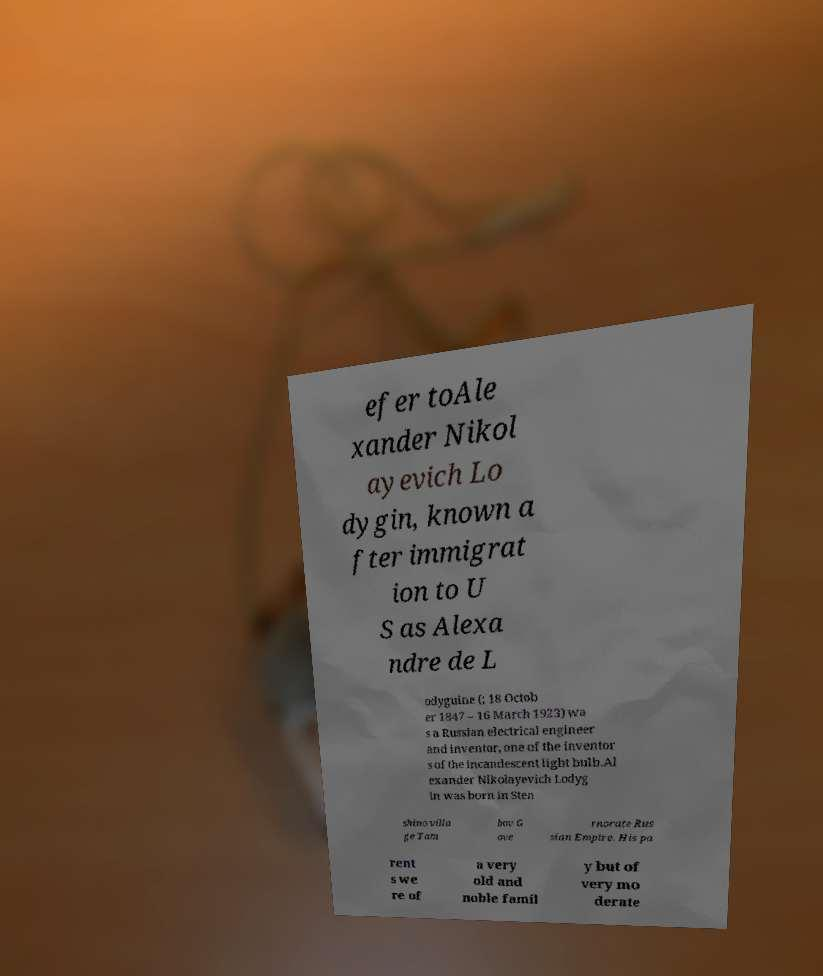Can you accurately transcribe the text from the provided image for me? efer toAle xander Nikol ayevich Lo dygin, known a fter immigrat ion to U S as Alexa ndre de L odyguine (; 18 Octob er 1847 – 16 March 1923) wa s a Russian electrical engineer and inventor, one of the inventor s of the incandescent light bulb.Al exander Nikolayevich Lodyg in was born in Sten shino villa ge Tam bov G ove rnorate Rus sian Empire. His pa rent s we re of a very old and noble famil y but of very mo derate 